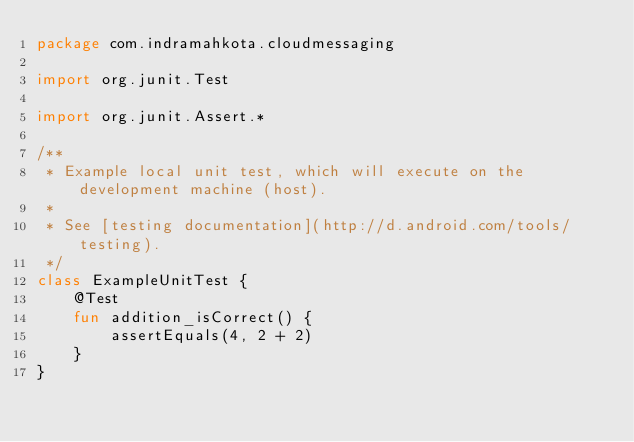Convert code to text. <code><loc_0><loc_0><loc_500><loc_500><_Kotlin_>package com.indramahkota.cloudmessaging

import org.junit.Test

import org.junit.Assert.*

/**
 * Example local unit test, which will execute on the development machine (host).
 *
 * See [testing documentation](http://d.android.com/tools/testing).
 */
class ExampleUnitTest {
    @Test
    fun addition_isCorrect() {
        assertEquals(4, 2 + 2)
    }
}</code> 